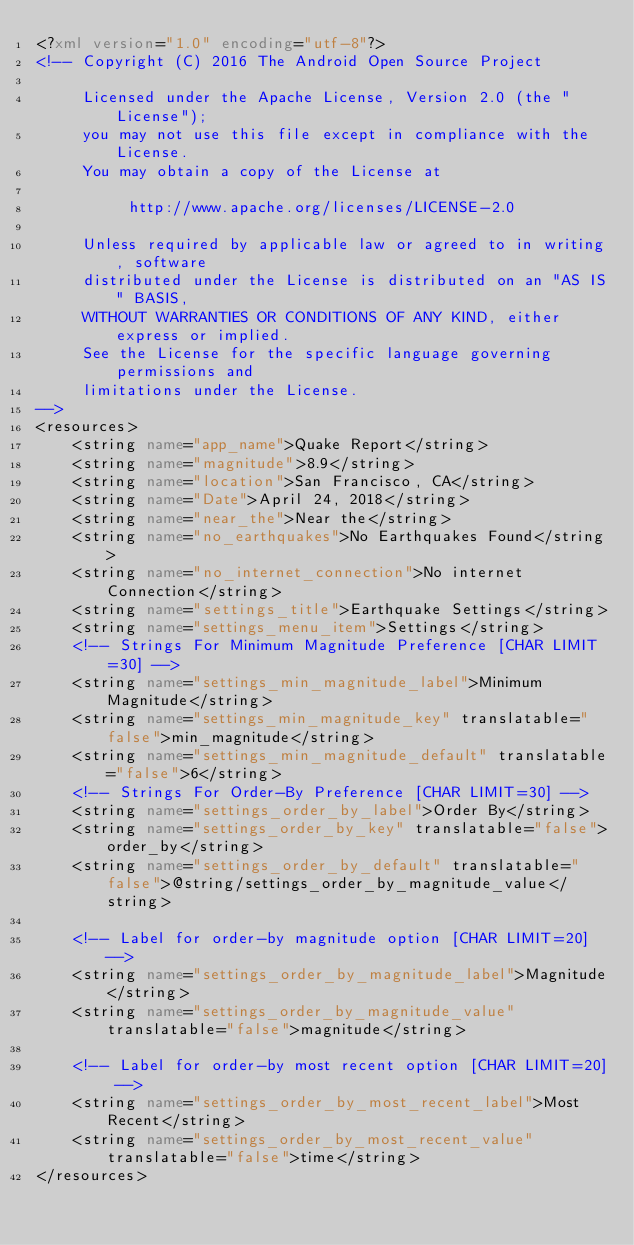Convert code to text. <code><loc_0><loc_0><loc_500><loc_500><_XML_><?xml version="1.0" encoding="utf-8"?>
<!-- Copyright (C) 2016 The Android Open Source Project

     Licensed under the Apache License, Version 2.0 (the "License");
     you may not use this file except in compliance with the License.
     You may obtain a copy of the License at

          http://www.apache.org/licenses/LICENSE-2.0

     Unless required by applicable law or agreed to in writing, software
     distributed under the License is distributed on an "AS IS" BASIS,
     WITHOUT WARRANTIES OR CONDITIONS OF ANY KIND, either express or implied.
     See the License for the specific language governing permissions and
     limitations under the License.
-->
<resources>
    <string name="app_name">Quake Report</string>
    <string name="magnitude">8.9</string>
    <string name="location">San Francisco, CA</string>
    <string name="Date">April 24, 2018</string>
    <string name="near_the">Near the</string>
    <string name="no_earthquakes">No Earthquakes Found</string>
    <string name="no_internet_connection">No internet Connection</string>
    <string name="settings_title">Earthquake Settings</string>
    <string name="settings_menu_item">Settings</string>
    <!-- Strings For Minimum Magnitude Preference [CHAR LIMIT=30] -->
    <string name="settings_min_magnitude_label">Minimum Magnitude</string>
    <string name="settings_min_magnitude_key" translatable="false">min_magnitude</string>
    <string name="settings_min_magnitude_default" translatable="false">6</string>
    <!-- Strings For Order-By Preference [CHAR LIMIT=30] -->
    <string name="settings_order_by_label">Order By</string>
    <string name="settings_order_by_key" translatable="false">order_by</string>
    <string name="settings_order_by_default" translatable="false">@string/settings_order_by_magnitude_value</string>

    <!-- Label for order-by magnitude option [CHAR LIMIT=20] -->
    <string name="settings_order_by_magnitude_label">Magnitude</string>
    <string name="settings_order_by_magnitude_value" translatable="false">magnitude</string>

    <!-- Label for order-by most recent option [CHAR LIMIT=20] -->
    <string name="settings_order_by_most_recent_label">Most Recent</string>
    <string name="settings_order_by_most_recent_value" translatable="false">time</string>
</resources>
</code> 